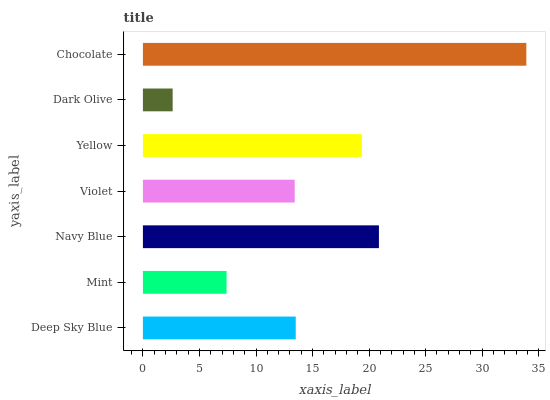Is Dark Olive the minimum?
Answer yes or no. Yes. Is Chocolate the maximum?
Answer yes or no. Yes. Is Mint the minimum?
Answer yes or no. No. Is Mint the maximum?
Answer yes or no. No. Is Deep Sky Blue greater than Mint?
Answer yes or no. Yes. Is Mint less than Deep Sky Blue?
Answer yes or no. Yes. Is Mint greater than Deep Sky Blue?
Answer yes or no. No. Is Deep Sky Blue less than Mint?
Answer yes or no. No. Is Deep Sky Blue the high median?
Answer yes or no. Yes. Is Deep Sky Blue the low median?
Answer yes or no. Yes. Is Navy Blue the high median?
Answer yes or no. No. Is Navy Blue the low median?
Answer yes or no. No. 